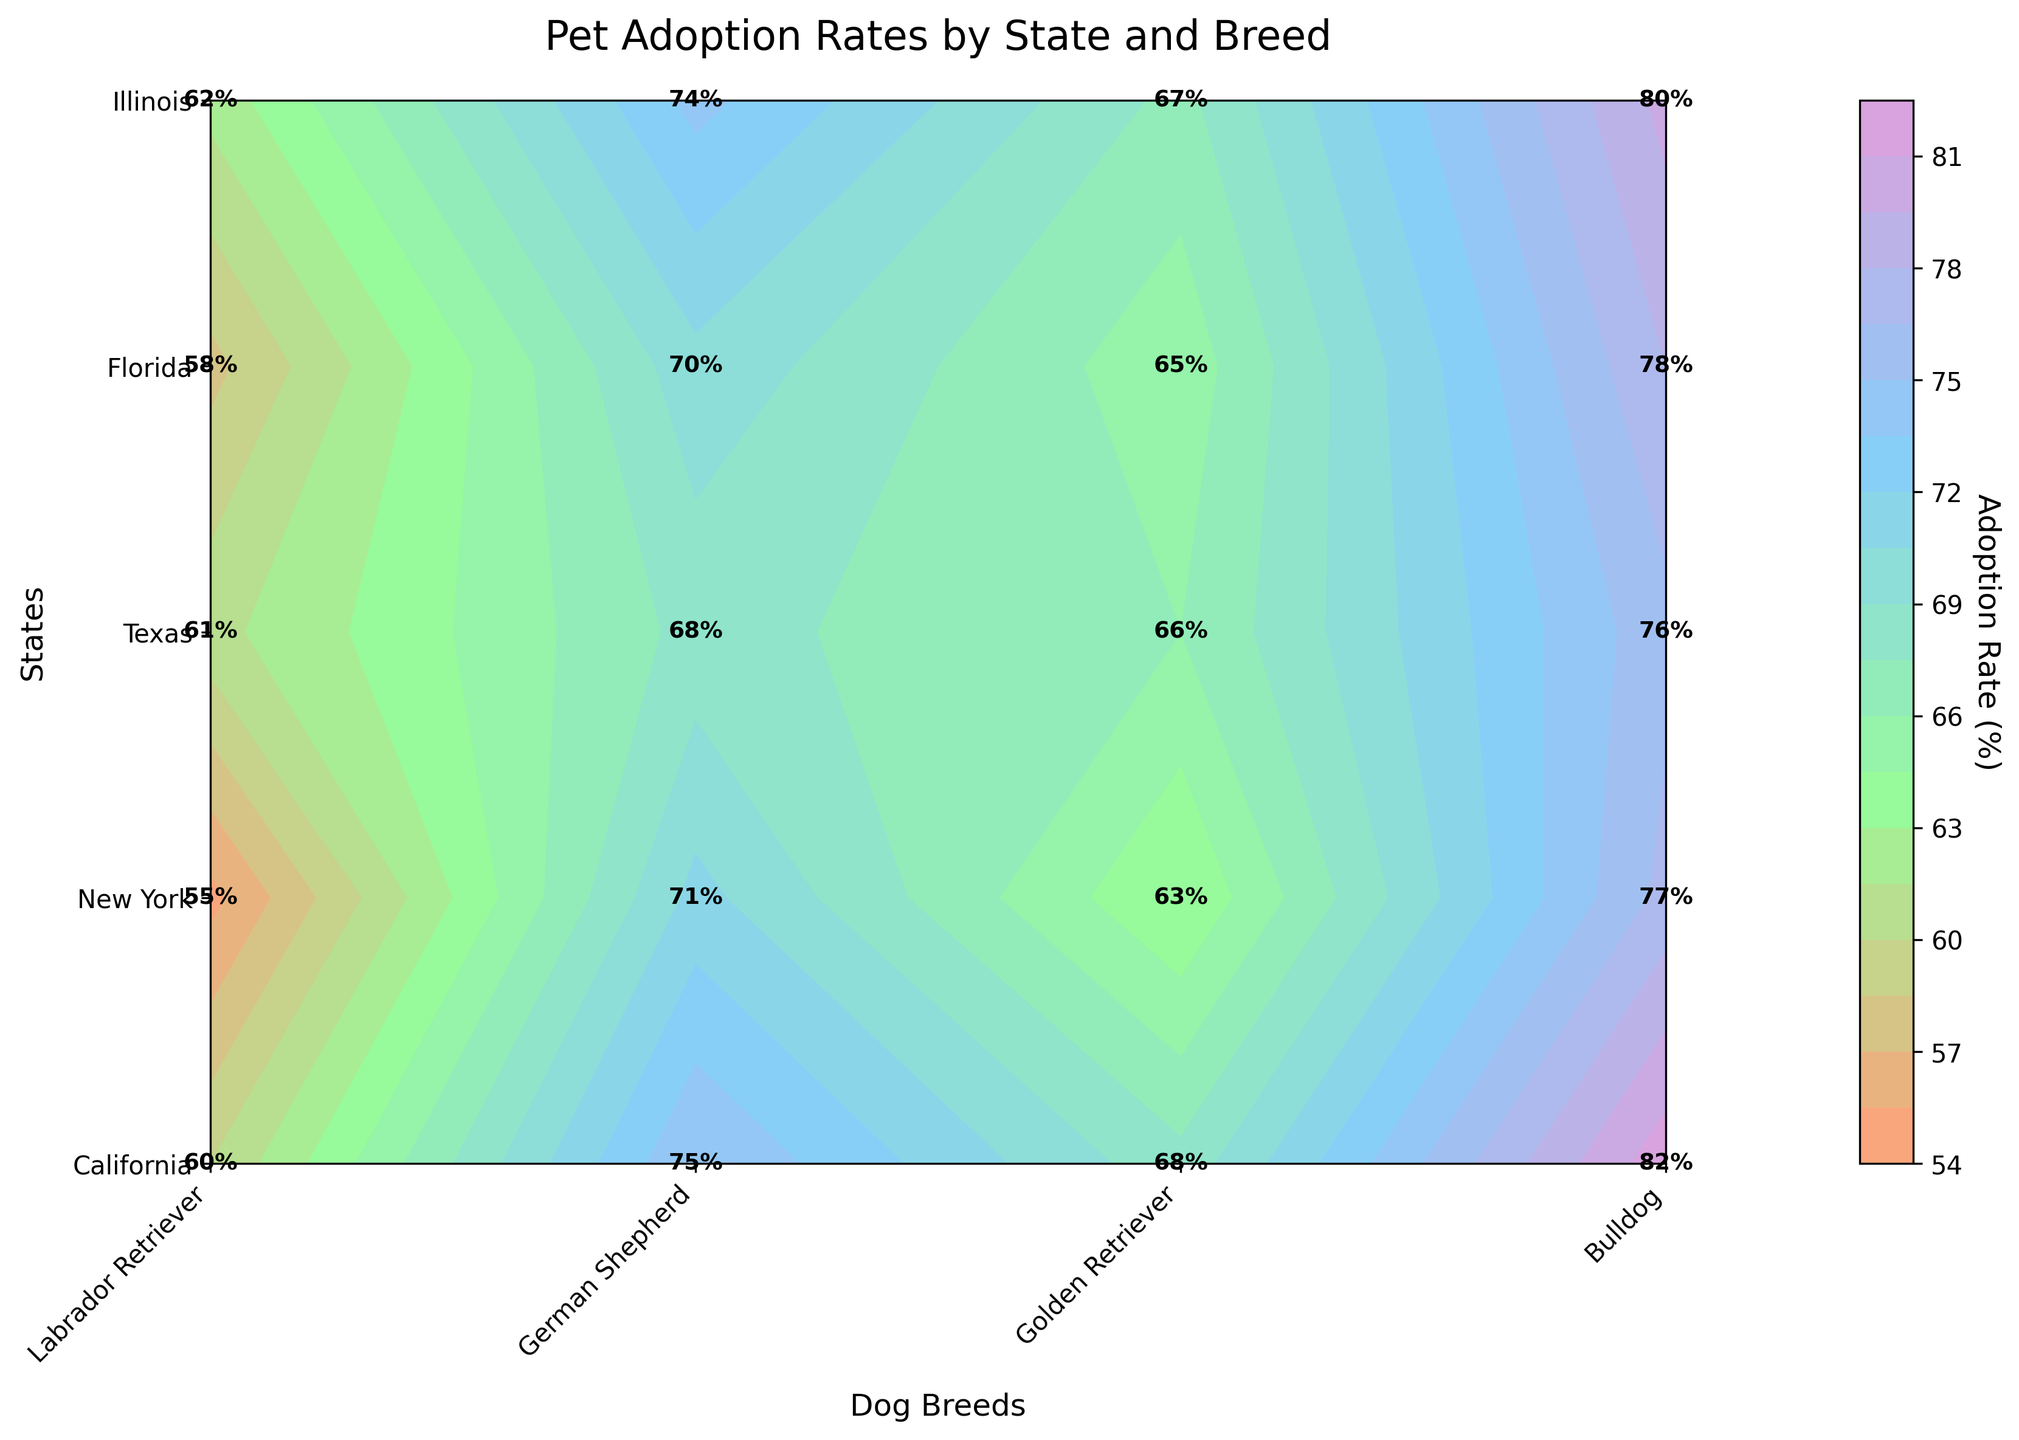What's the title of the plot? The title of the plot is usually found at the top of the figure, often in larger and bold text for emphasis. Here, it reads, "Pet Adoption Rates by State and Breed."
Answer: Pet Adoption Rates by State and Breed What is the highest adoption rate shown, and in which state and breed is it observed? Looking at the plot, the highest adoption rate is seen in California for the Labrador Retriever breed, where it is marked as 82%.
Answer: 82%, California, Labrador Retriever Which state has the lowest adoption rate for Bulldogs? By closely inspecting all the states listed on the Y-axis and the corresponding adoption rates for Bulldogs, the lowest value, 55%, is observed in Florida.
Answer: Florida What is the average adoption rate for Golden Retrievers across all states? Sum the adoption rates for Golden Retrievers from all the states (68+65+67+63+66) and divide by the number of states (5). The total is 329, and the average is 329/5 = 65.8.
Answer: 65.8% Which breed shows the most variability in adoption rates across the states, and how can you tell? Comparing the spread between the highest and lowest values for each breed: Labrador Retriever (82-76=6%), German Shepherd (75-68=7%), Golden Retriever (68-63=5%), Bulldog (62-55=7%). Both German Shepherd and Bulldog show the most variability with a range of 7%.
Answer: German Shepherd and Bulldog What is the difference in adoption rates between Florida and Illinois for German Shepherds? Locate the adoption rates for German Shepherds in Florida (71%) and Illinois (68%). The difference is 71 - 68 = 3%.
Answer: 3% Which state has consistently high adoption rates across all breeds? Evaluating each state across the breeds, California has the highest or second-highest adoption rates consistently for all breeds, indicating overall high adoption rates.
Answer: California Which breed's adoption rate is closest to the average adoption rate of all breeds in New York? First, calculate the average adoption rate for all breeds in New York (78+70+65+58)/4 = 67.75%. Then compare this average with the adoption rates of each breed; the Golden Retriever at 65% is closest.
Answer: Golden Retriever What is the median adoption rate for German Shepherds? List the adoption rates for German Shepherds across the states (75, 70, 74, 71, 68). Ordering them: 68, 70, 71, 74, 75, the middle value is 71.
Answer: 71% How does the adoption rate of Bulldogs in Texas compare to the overall average adoption rate for Bulldogs? The adoption rate for Bulldogs in Texas is 62%. Calculate the average adoption rate for Bulldogs across all states: (60+58+62+55+61)/5 = 59.2%. Texas's rate is higher by 62 - 59.2 = 2.8%.
Answer: Higher by 2.8% 